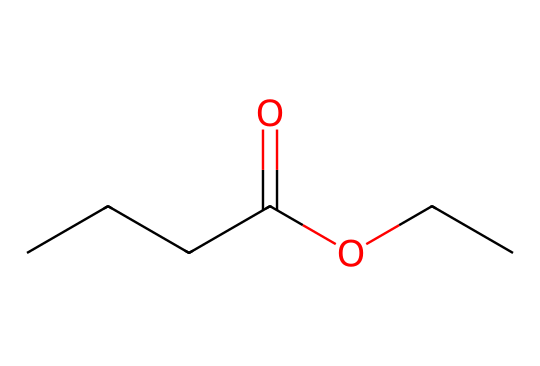What is the name of this ester? The ester is formed from butanoic acid and ethanol, which gives it the name ethyl butyrate.
Answer: ethyl butyrate How many carbon atoms are in ethyl butyrate? From the SMILES, there are 5 carbon atoms: 4 from the butanoic acid part and 1 from the ethyl part.
Answer: five What functional groups are present in ethyl butyrate? The structure shows both an ester group (-COO-) and an alkyl group (-C2H5 from ethyl), indicating the presence of an ester functional group.
Answer: ester Which part of the molecule gives ethyl butyrate its fruity smell? The butanoate portion contributes to the characteristic fruity scent commonly associated with esters, particularly when it forms esters with alcohols.
Answer: butanoate What type of reaction is used to form esters like ethyl butyrate? The formation of esters from carboxylic acids and alcohols occurs through a condensation reaction known as esterification, specifically via the elimination of water.
Answer: esterification What is the total number of hydrogen atoms in ethyl butyrate? Counting the hydrogen atoms from the full structure based on carbons, the total is 10 hydrogen atoms: there are 3 from the butanoic acid and 5 from the ethyl group.
Answer: ten 